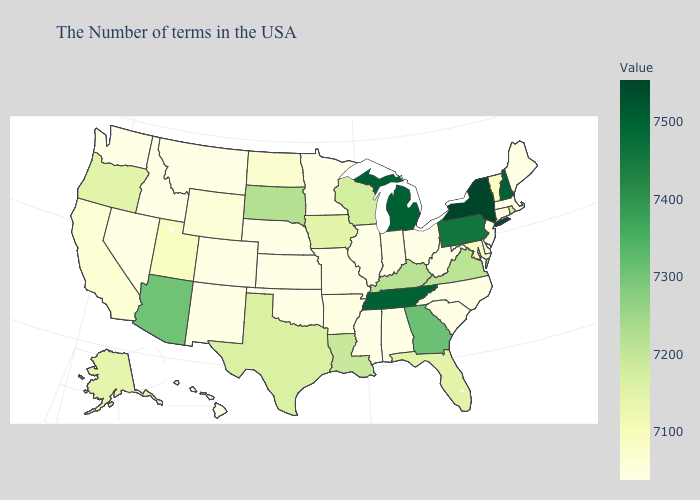Which states have the highest value in the USA?
Concise answer only. New York. Among the states that border Indiana , which have the highest value?
Quick response, please. Michigan. Among the states that border Missouri , which have the lowest value?
Keep it brief. Illinois, Kansas, Nebraska, Oklahoma. Which states have the lowest value in the USA?
Concise answer only. Maine, Massachusetts, Connecticut, New Jersey, Delaware, North Carolina, West Virginia, Ohio, Indiana, Alabama, Illinois, Mississippi, Missouri, Minnesota, Kansas, Nebraska, Oklahoma, Colorado, New Mexico, Montana, Idaho, Washington, Hawaii. 